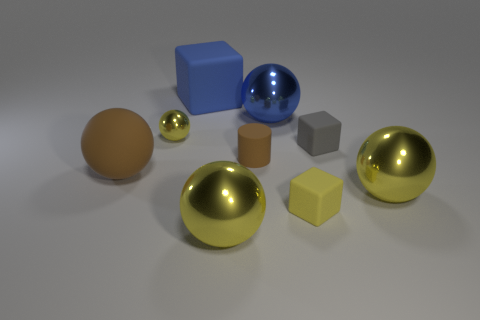Add 1 brown matte spheres. How many objects exist? 10 Subtract all small spheres. How many spheres are left? 4 Subtract all balls. How many objects are left? 4 Subtract 1 blocks. How many blocks are left? 2 Subtract all blue blocks. How many blocks are left? 2 Subtract all cyan spheres. Subtract all gray cylinders. How many spheres are left? 5 Subtract all brown blocks. How many red spheres are left? 0 Subtract all tiny blue matte blocks. Subtract all brown rubber spheres. How many objects are left? 8 Add 7 large blue matte cubes. How many large blue matte cubes are left? 8 Add 7 blocks. How many blocks exist? 10 